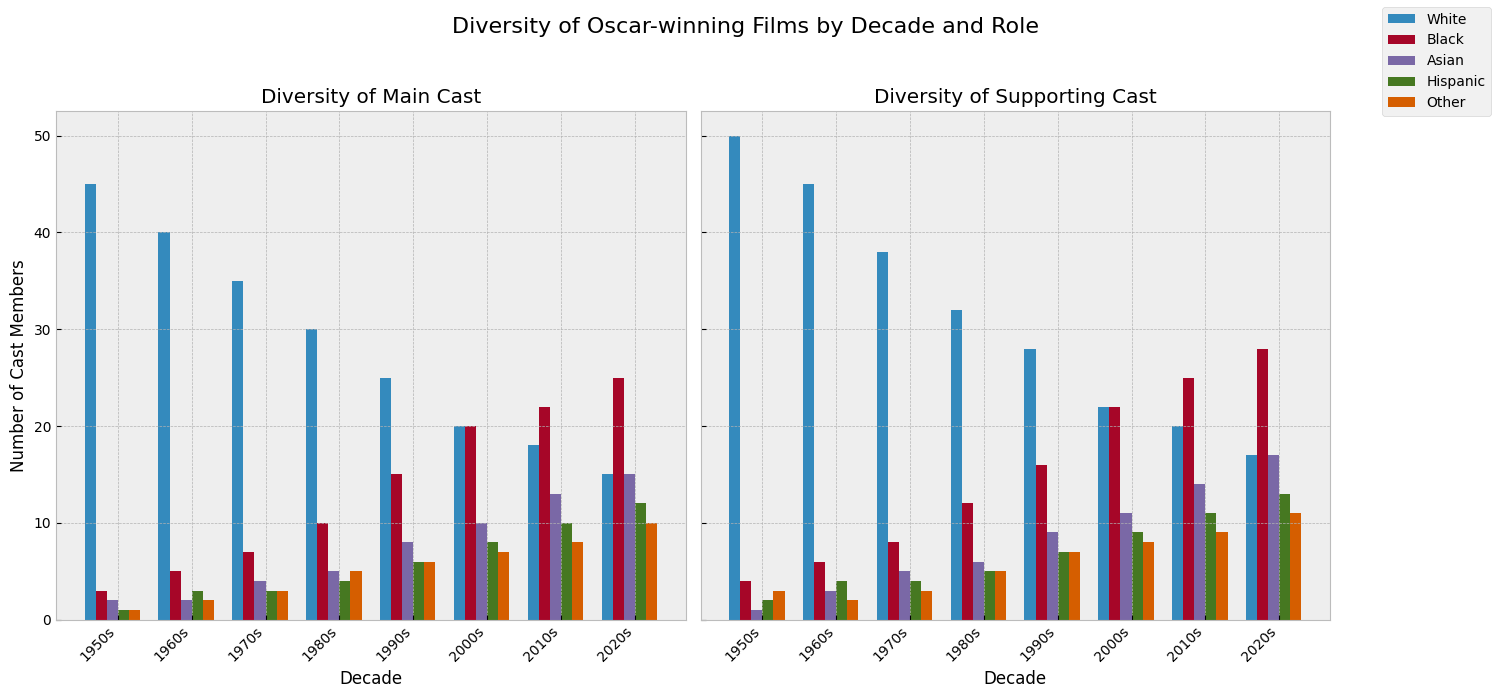What is the total number of White main cast members in the 1950s and 1960s? Add the number of White main cast members in the 1950s (45) to those in the 1960s (40). 45 + 40 = 85
Answer: 85 Which decade has the highest number of Asian main cast members? Compare the heights of the bars representing Asian main cast members across all decades. The tallest bar is in the 2020s with 15 members.
Answer: 2020s Is the number of Black supporting cast members in the 2020s greater than in the 1960s? Compare the height of the Black supporting cast bar in the 2020s (28) to that in the 1960s (6). 28 is greater than 6, so yes.
Answer: Yes By how many did the number of Hispanic supporting cast members increase from the 1980s to the 2010s? Subtract the number of Hispanic supporting cast members in the 1980s (5) from those in the 2010s (11). 11 - 5 = 6
Answer: 6 What is the average number of 'Other' main cast members across the 1950s, 1960s, and 1970s? Add the number of 'Other' main cast members in the 1950s (1), 1960s (2), and 1970s (3). Divide by the number of decades (3). (1 + 2 + 3) / 3 = 2
Answer: 2 In which decade did the main cast have the lowest number of White members, and what is that number? Identify the lowest bar for White main cast members across all decades. The lowest is in the 2020s with 15 members.
Answer: 2020s, 15 What is the total number of Black and Hispanic supporting cast members in the 2010s? Add the number of Black supporting cast members (25) to Hispanic supporting cast members (11) in the 2010s. 25 + 11 = 36
Answer: 36 Are there more Hispanic main cast members or Hispanic supporting cast members in the 2000s? Compare the height of the Hispanic main cast bar (8) to the Hispanic supporting cast bar (9) in the 2000s. The Hispanic supporting cast bar is taller.
Answer: Hispanic supporting cast Which role has shown a more significant increase in diversity from the 1950s to the 2020s, main cast or supporting cast? Compare the differences in height for each category between the 1950s and 2020s for both roles. Supporting cast shows larger increases across more categories (e.g., Black: 4 to 28, Asian: 1 to 17) compared to main cast.
Answer: Supporting cast How did the number of Asian supporting cast members change between the 1970s and 1980s? Compare the number of Asian supporting cast members in the 1970s (5) to those in the 1980s (6). The increase is by 1.
Answer: Increased by 1 